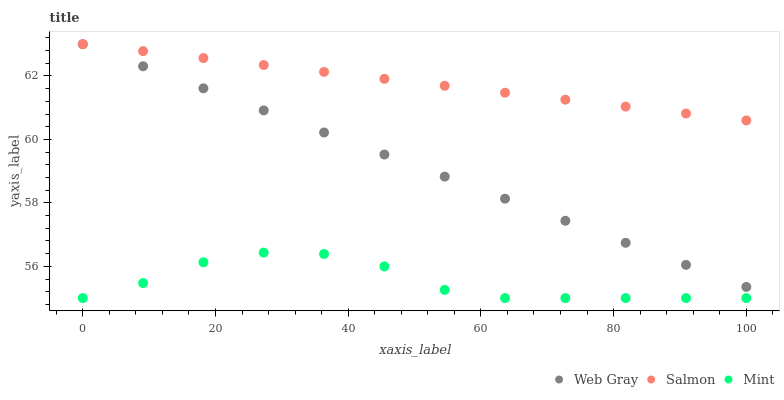Does Mint have the minimum area under the curve?
Answer yes or no. Yes. Does Salmon have the maximum area under the curve?
Answer yes or no. Yes. Does Web Gray have the minimum area under the curve?
Answer yes or no. No. Does Web Gray have the maximum area under the curve?
Answer yes or no. No. Is Web Gray the smoothest?
Answer yes or no. Yes. Is Mint the roughest?
Answer yes or no. Yes. Is Salmon the smoothest?
Answer yes or no. No. Is Salmon the roughest?
Answer yes or no. No. Does Mint have the lowest value?
Answer yes or no. Yes. Does Web Gray have the lowest value?
Answer yes or no. No. Does Salmon have the highest value?
Answer yes or no. Yes. Is Mint less than Web Gray?
Answer yes or no. Yes. Is Web Gray greater than Mint?
Answer yes or no. Yes. Does Salmon intersect Web Gray?
Answer yes or no. Yes. Is Salmon less than Web Gray?
Answer yes or no. No. Is Salmon greater than Web Gray?
Answer yes or no. No. Does Mint intersect Web Gray?
Answer yes or no. No. 